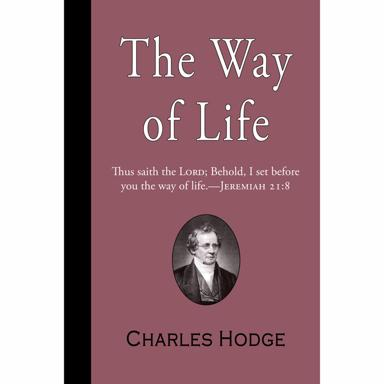How has the reception of Hodge's works changed over time? Initially embraced widely within Presbyterian and broader Reformed communities, Hodge's works continue to be revered but have sparked significant dialogue and debate. Over time, perspectives on issues like predestination, biblical inerrancy, and the role of reason in faith, central to Hodge's teachings, have evolved. Today, his works are studied both for their historical importance and ongoing relevance in theological debates, particularly sparking discussions on interpreting doctrine in modern contexts. 